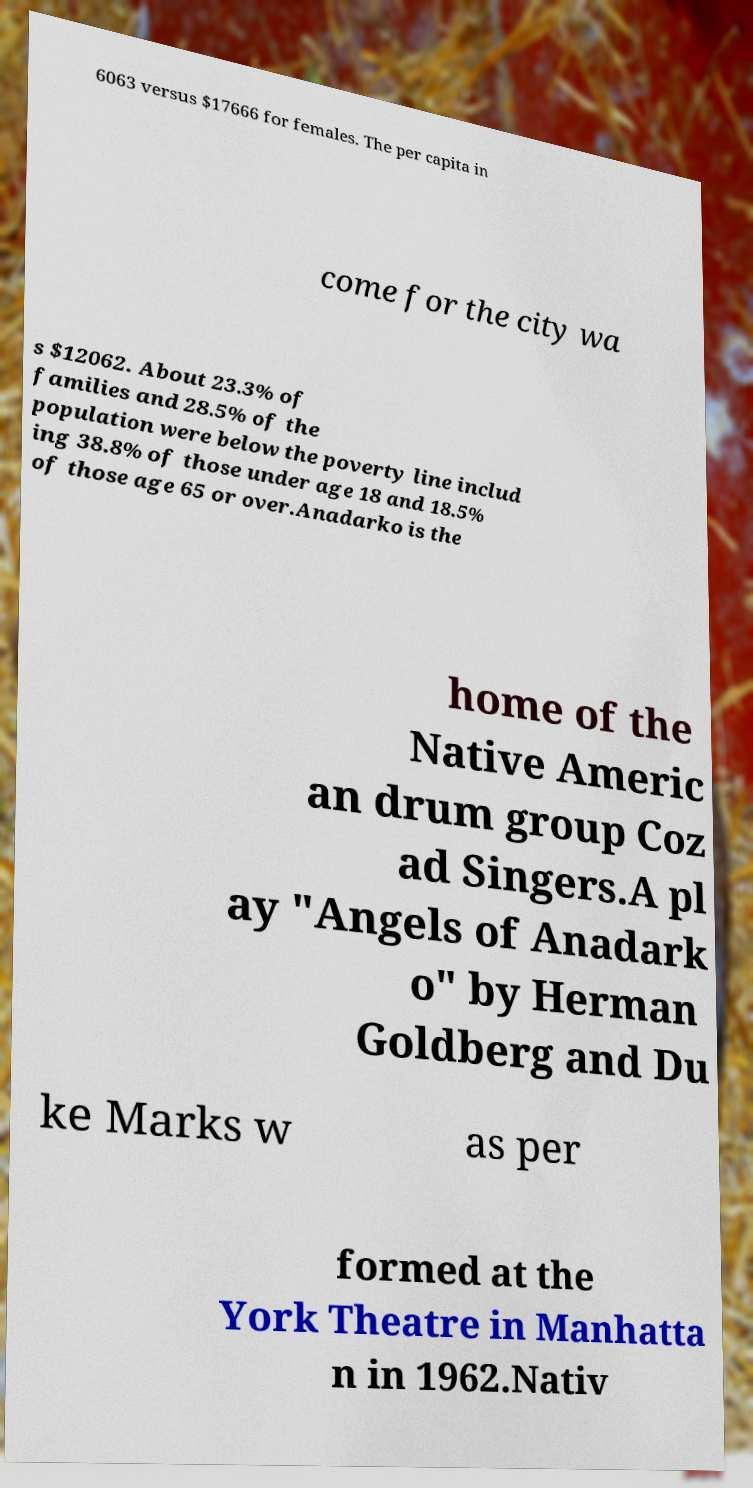Could you assist in decoding the text presented in this image and type it out clearly? 6063 versus $17666 for females. The per capita in come for the city wa s $12062. About 23.3% of families and 28.5% of the population were below the poverty line includ ing 38.8% of those under age 18 and 18.5% of those age 65 or over.Anadarko is the home of the Native Americ an drum group Coz ad Singers.A pl ay "Angels of Anadark o" by Herman Goldberg and Du ke Marks w as per formed at the York Theatre in Manhatta n in 1962.Nativ 